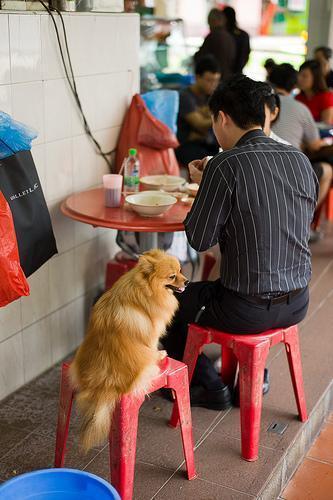How many dogs are in the picture?
Give a very brief answer. 1. 